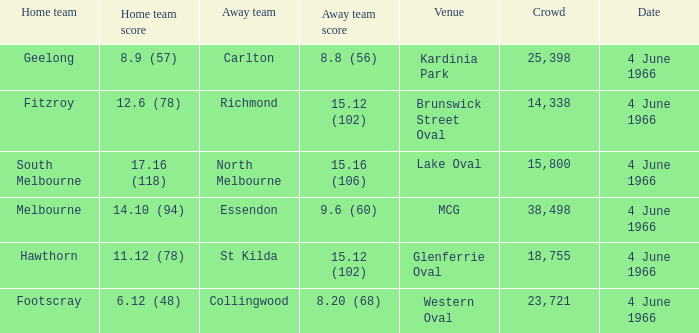What is the score of the away team that played home team Geelong? 8.8 (56). 